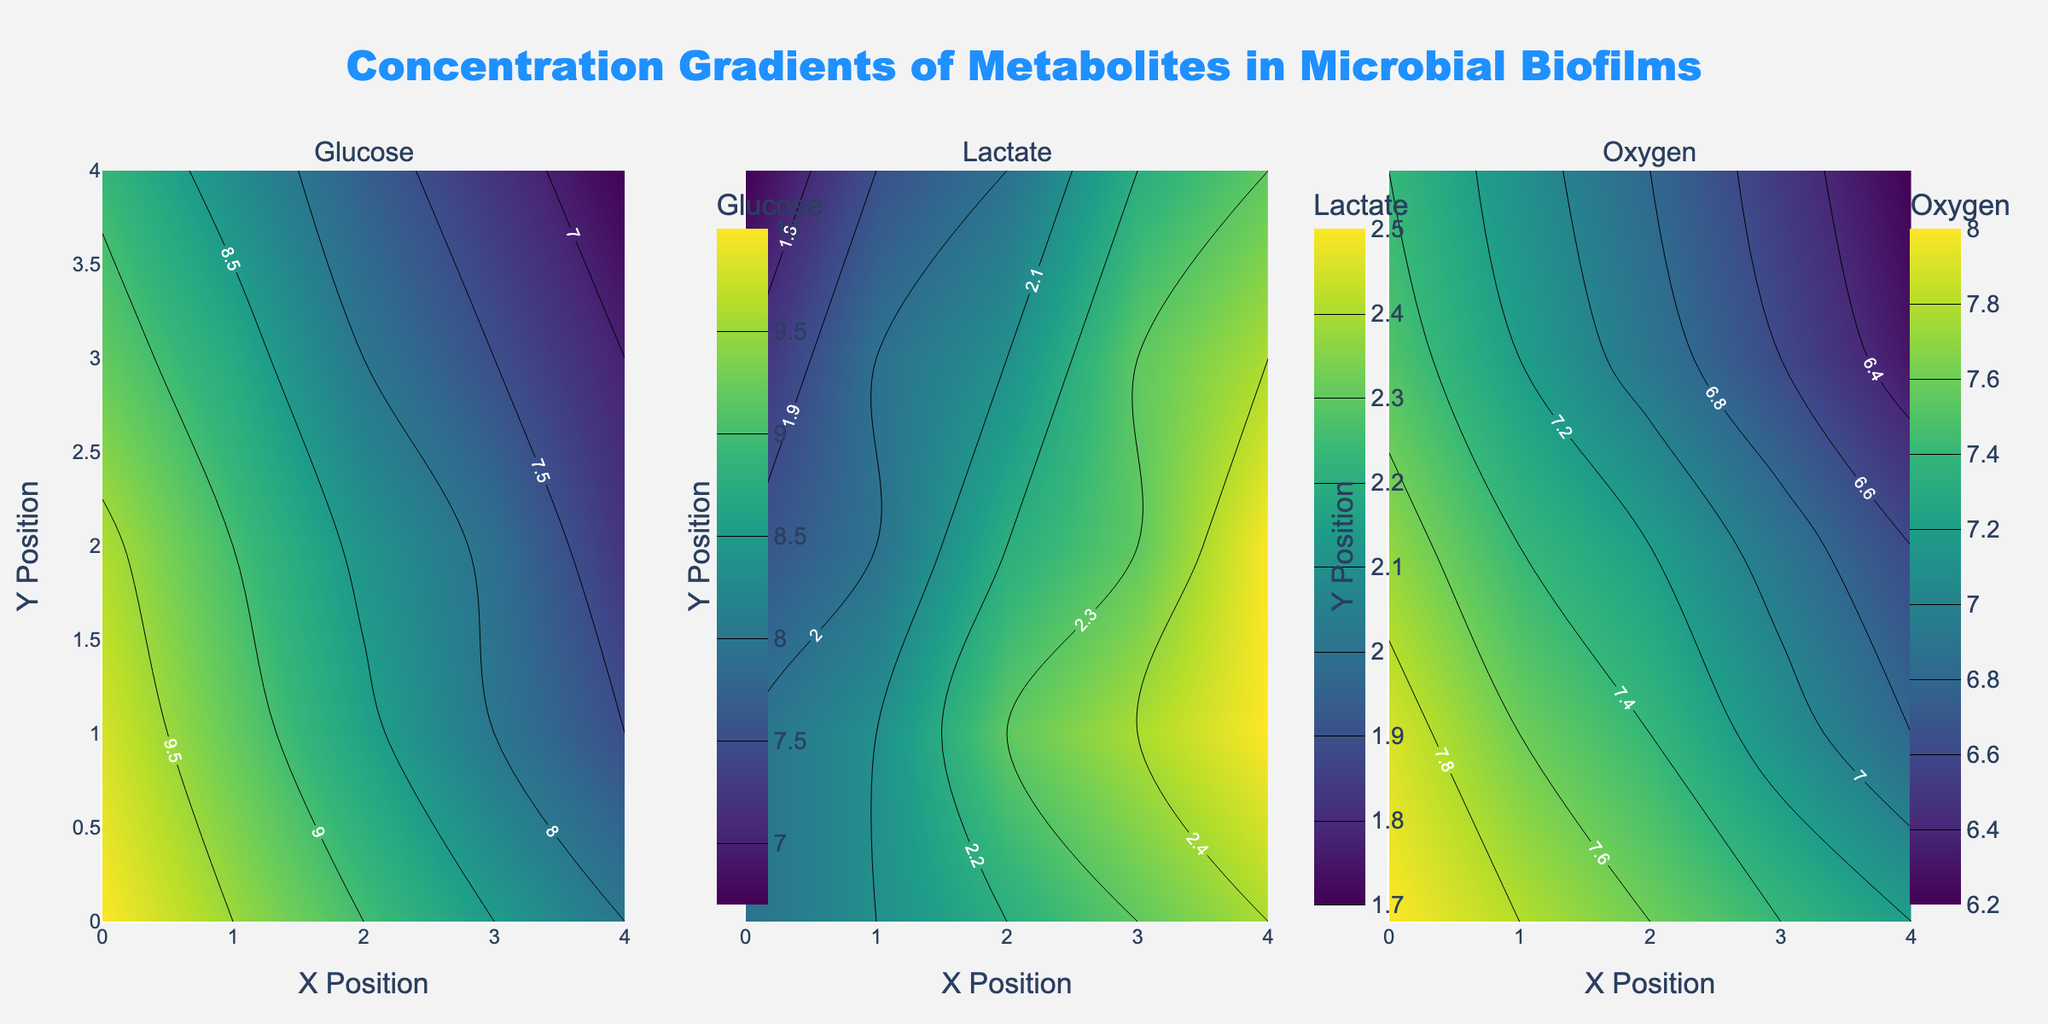What is the title of the figure? The title is located at the top of the figure. It is usually highlighted and often written in a larger font size for emphasis.
Answer: Concentration Gradients of Metabolites in Microbial Biofilms What metabolite has the highest concentration near (0,0)? Look at the individual contour plots for the point (0, 0). Identify which metabolite has the highest value at this coordinate.
Answer: Glucose Comparing the concentration of Lactate at (1,1) and (4,4), which is higher? Locate the values at (1,1) and (4,4) on the Lactate contour plot. Compare the two values to determine which is higher.
Answer: (1,1) What is the average concentration of Oxygen at (2,2) across all metabolites? Sum the concentrations of Glucose, Lactate, and Oxygen at (2,2). Then, divide by the number of metabolites (3) to find the average.
Answer: (8.4 + 2.2 + 7.2) / 3 = 5.93 Which direction does the concentration of Glucose decrease the most rapidly from (0,0)? Observe the gradient lines in the Glucose contour plot, starting from (0,0). Identify the direction where the contour lines are closest together, indicating the steepest gradient.
Answer: Positive x-direction How does the concentration of Oxygen change from (0,0) to (4,0)? Check the Oxygen contour plot for values at (0,0) and (4,0). Note the change in values to see how the concentration increases or decreases along this path.
Answer: Decreases Is there any point where the concentrations of all three metabolites are equal? Look at the contour plots and compare values across all three metabolites at each coordinate point (x,y) to see if they match.
Answer: No What is the range of concentration values for Lactate? Identify the minimum and maximum concentrations of Lactate from the contour plot. Subtract the minimum from the maximum to determine the range.
Answer: Range = 2.5 - 1.7 = 0.8 At which (x, y) coordinate is the lowest concentration of Glucose found? Examine the Glucose contour plot and identify the coordinate with the lowest value.
Answer: (4,4) Which metabolite shows the most uniform distribution across the biofilm? By comparing the contour plots, observe which metabolite has the most evenly spaced gradient lines, indicating a uniform distribution.
Answer: Lactate 